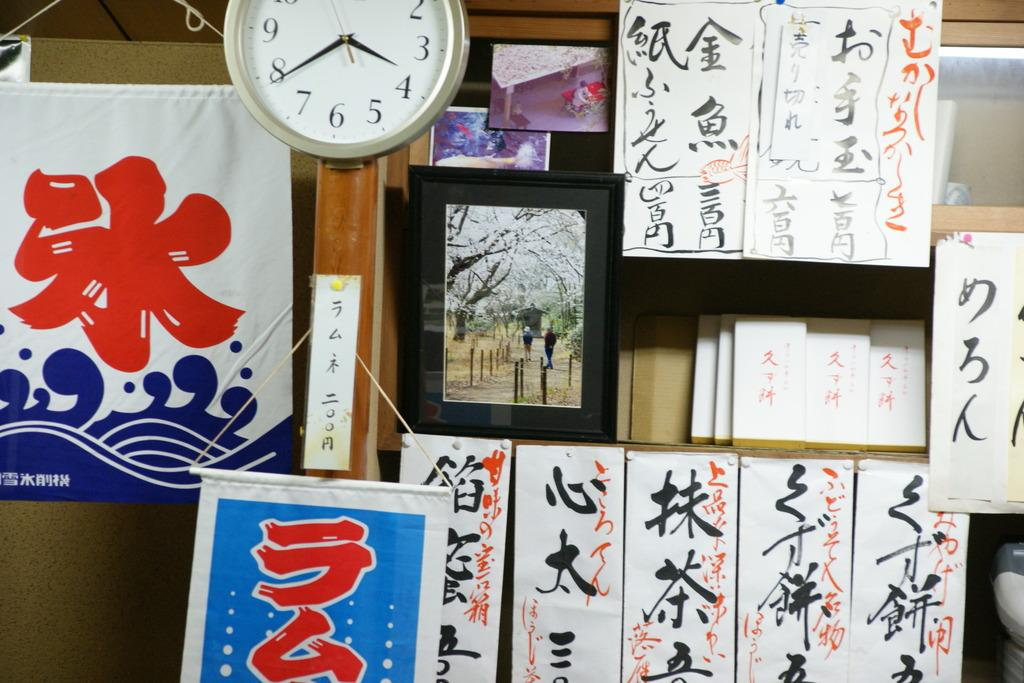What type of items can be seen on the wall or shelves in the image? There are photo frames, a watch, scriptures, and books in the image. What might be used to tell time in the image? There is a watch in the image that can be used to tell time. What type of items might contain written content in the image? The scriptures and books in the image contain written content. How are the photo frames, watch, scriptures, and books arranged in the image? They are either on the wall or on shelves in the image. Can you see a bat flying in the image? No, there is no bat visible in the image. Is there a man holding a pen in the image? No, there is no man or pen present in the image. 